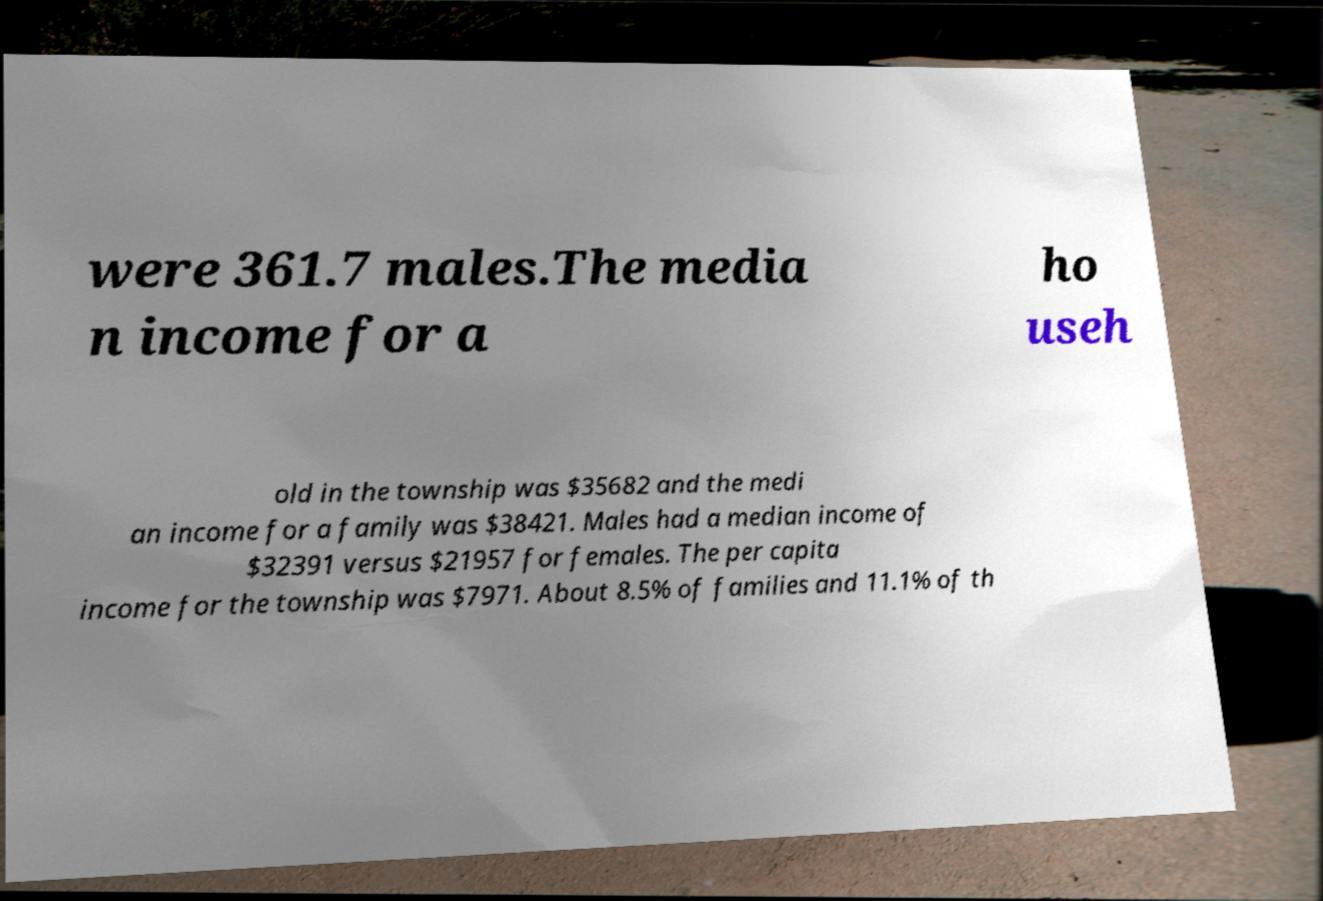I need the written content from this picture converted into text. Can you do that? were 361.7 males.The media n income for a ho useh old in the township was $35682 and the medi an income for a family was $38421. Males had a median income of $32391 versus $21957 for females. The per capita income for the township was $7971. About 8.5% of families and 11.1% of th 